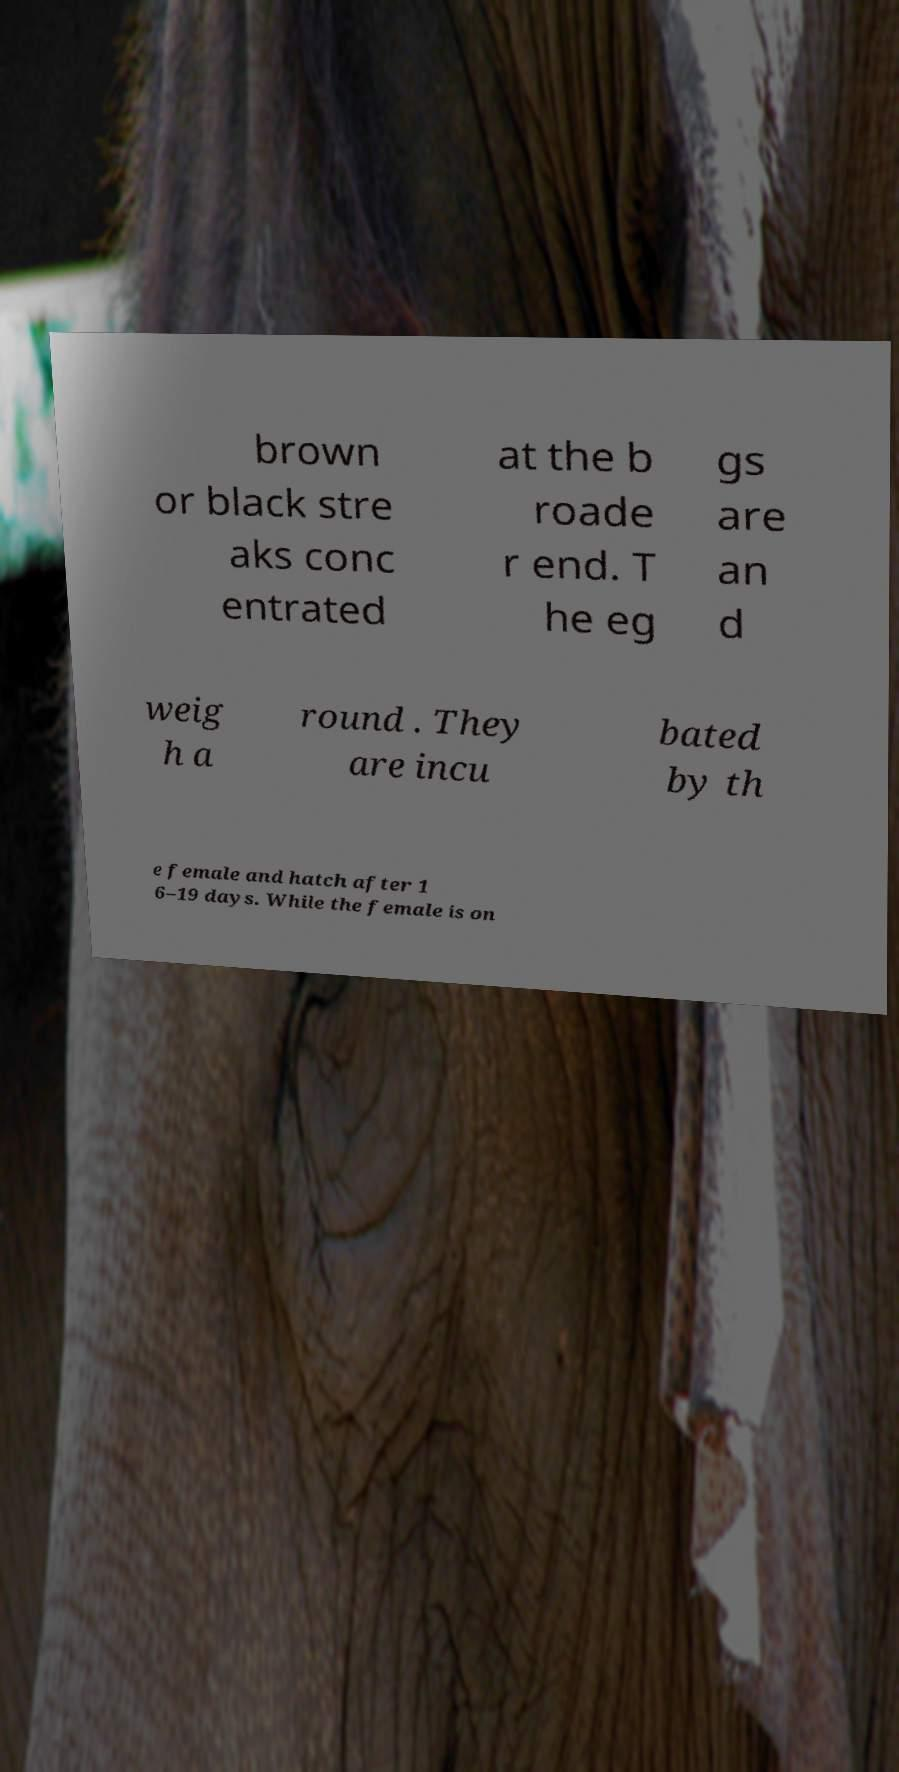Please identify and transcribe the text found in this image. brown or black stre aks conc entrated at the b roade r end. T he eg gs are an d weig h a round . They are incu bated by th e female and hatch after 1 6–19 days. While the female is on 